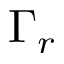Convert formula to latex. <formula><loc_0><loc_0><loc_500><loc_500>\Gamma _ { r }</formula> 